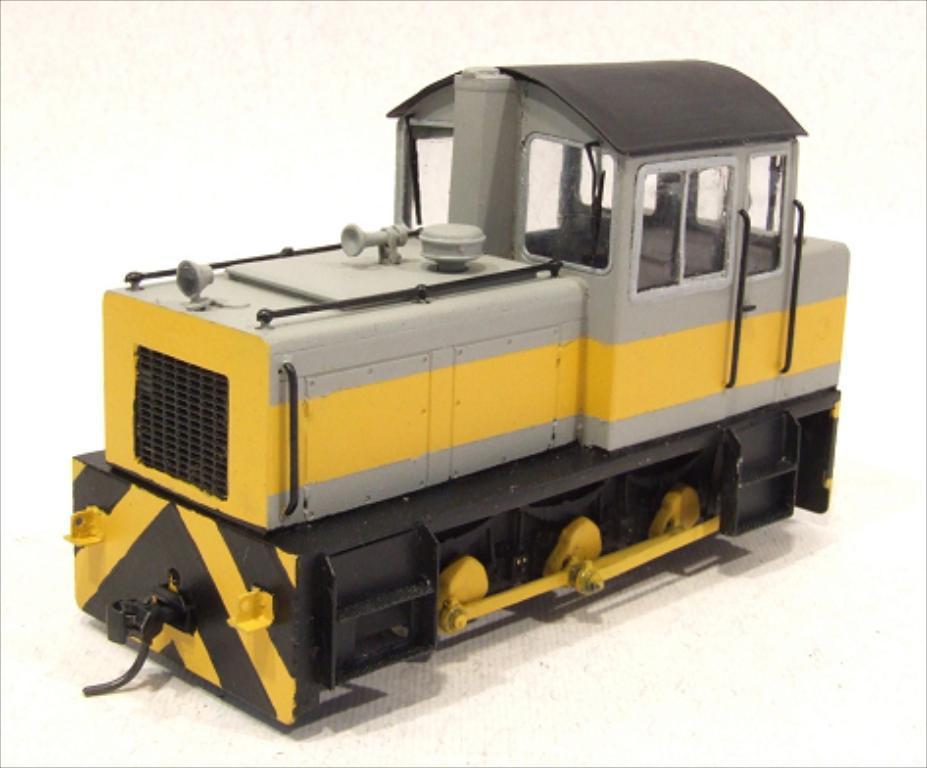Can you describe this image briefly? In the center of the image a toy train is present. 